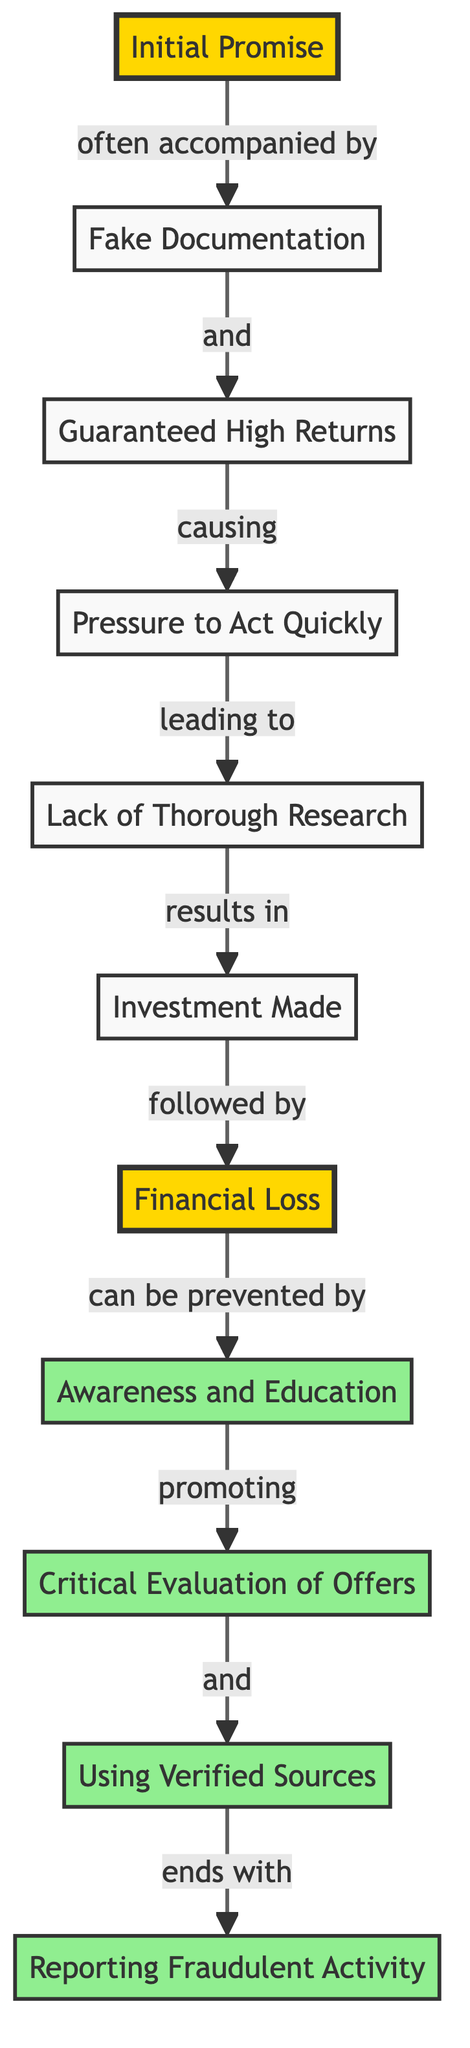What is the starting point of the flow? The flow begins at the node labeled "Initial Promise", which is the first node connected to others in the diagram, indicating the start of fraudulent schemes.
Answer: Initial Promise How many nodes are in the diagram? By counting the nodes listed in the data, there are 11 distinct entities representing various stages of the investment fraud process.
Answer: 11 What is the relationship between 'financial loss' and 'awareness and education'? The edge connects 'financial loss' to 'awareness and education' and is labeled "can be prevented by", indicating that awareness and education can help avert financial loss.
Answer: can be prevented by What leads to 'investment made'? The node 'investment made' is reached after passing through 'insufficient research', which shows that a lack of thorough research typically results in making an investment.
Answer: Lack of Thorough Research What comes after 'pressure to act quickly'? Following 'pressure to act quickly', the next node reached is 'insufficient research', demonstrating that pressure can cause individuals to skip adequate research.
Answer: Lack of Thorough Research Which node follows 'investment made'? The node directly following 'investment made' is 'financial loss', showcasing the outcome of making an investment under fraudulent circumstances.
Answer: Financial Loss What two nodes promote the evaluation of offers? The nodes 'awareness and education' and 'verified sources' are both connected to 'critical evaluation', promoting a deeper scrutiny of offers received.
Answer: Awareness and Education, Verified Sources How is 'reporting fraud' related to 'using verified sources'? The relationship is direct; the edge connecting 'using verified sources' to 'reporting fraud' is labeled "ends with", indicating that using verified sources culminates in reporting fraudulent activity.
Answer: ends with What is the first node that fraudulent schemes often include? The first node often mentioned in relation to fraudulent schemes is 'fake documentation', which usually accompanies the initial promise.
Answer: Fake Documentation What is a critical step to prevent financial loss? The critical step identified in the diagram to prevent financial loss is 'awareness and education', showing its significance in combating fraud.
Answer: Awareness and Education 